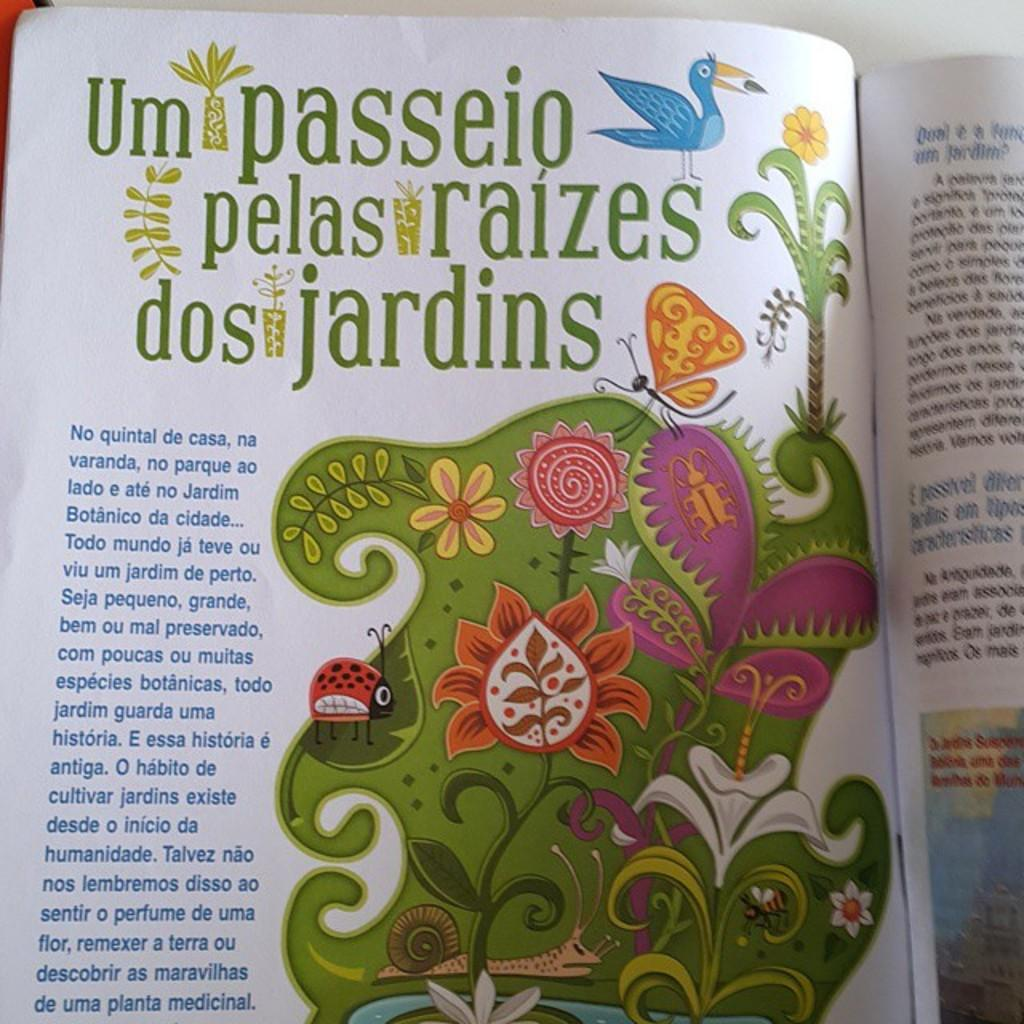<image>
Summarize the visual content of the image. A spanish magazine is open to an article about gardens. 